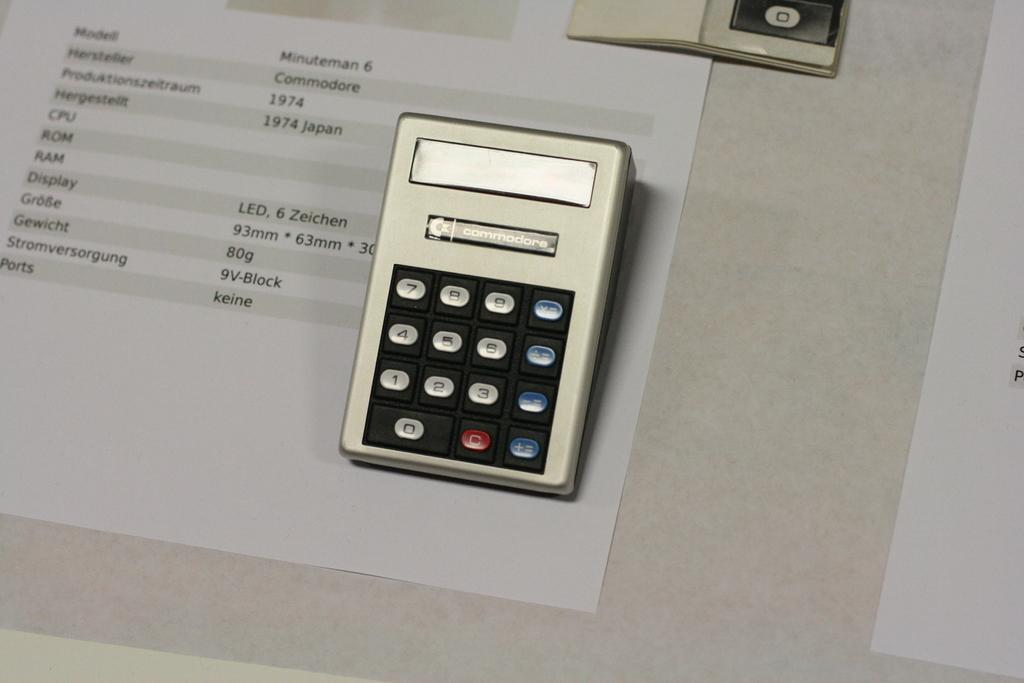Provide a one-sentence caption for the provided image. A small electronic device with the name commodore labeled across the top. 